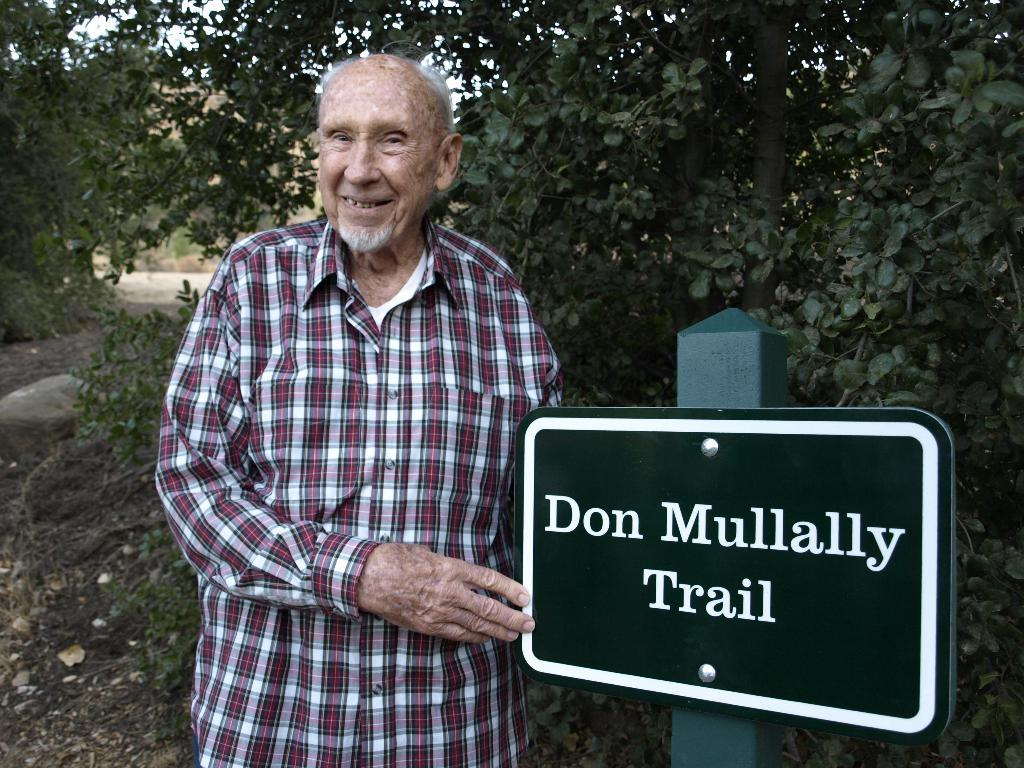Who or what is present in the image? There is a person in the image. What is attached to the pole in the image? There is a board with text on it attached to the pole. What can be seen on the ground in the image? The ground is visible in the image. What type of vegetation is present in the image? There are trees and plants in the image. What is visible in the background of the image? The sky is visible in the image. How does the person tie a knot with the water in the image? There is no water present in the image, and the person is not tying a knot. 